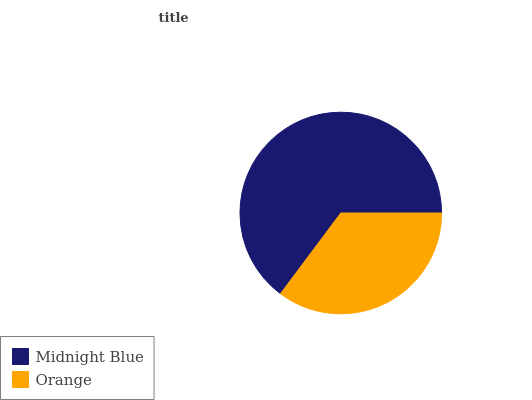Is Orange the minimum?
Answer yes or no. Yes. Is Midnight Blue the maximum?
Answer yes or no. Yes. Is Orange the maximum?
Answer yes or no. No. Is Midnight Blue greater than Orange?
Answer yes or no. Yes. Is Orange less than Midnight Blue?
Answer yes or no. Yes. Is Orange greater than Midnight Blue?
Answer yes or no. No. Is Midnight Blue less than Orange?
Answer yes or no. No. Is Midnight Blue the high median?
Answer yes or no. Yes. Is Orange the low median?
Answer yes or no. Yes. Is Orange the high median?
Answer yes or no. No. Is Midnight Blue the low median?
Answer yes or no. No. 